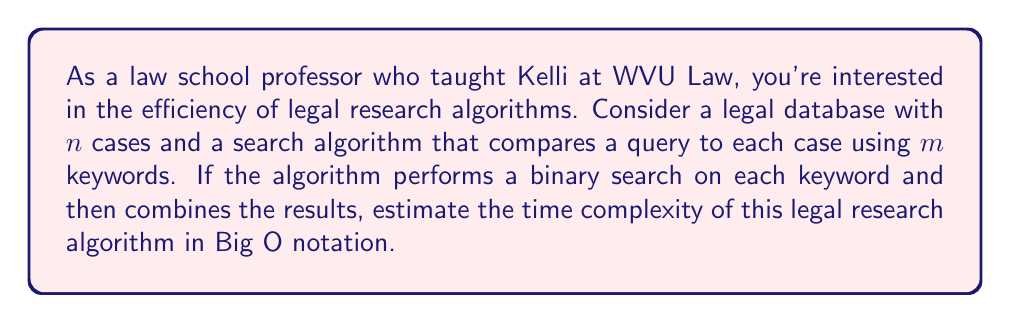Could you help me with this problem? Let's break this down step-by-step:

1) For each of the $n$ cases in the database:
   - The algorithm performs $m$ keyword searches
   - Each keyword search is a binary search

2) The time complexity of a binary search is $O(\log k)$, where $k$ is the number of elements being searched. In this case, let's assume $k$ is the average number of words in a case.

3) For each case, the algorithm performs $m$ binary searches:
   $O(m \cdot \log k)$

4) This is done for all $n$ cases:
   $O(n \cdot m \cdot \log k)$

5) After searching, the algorithm needs to combine the results. In the worst case, this could involve looking at all $n$ cases again:
   $O(n)$

6) The total time complexity is the sum of the search and combination steps:
   $O(n \cdot m \cdot \log k + n)$

7) Since $n \cdot m \cdot \log k$ is likely to be much larger than $n$ for any significant database, we can simplify this to:
   $O(n \cdot m \cdot \log k)$

This represents the upper bound of the time complexity for this legal research algorithm.
Answer: $O(n \cdot m \cdot \log k)$, where $n$ is the number of cases, $m$ is the number of keywords, and $k$ is the average number of words in a case. 